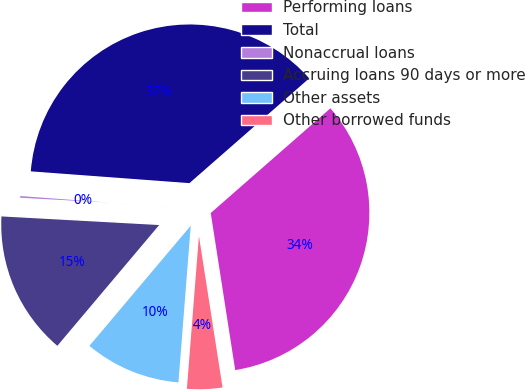<chart> <loc_0><loc_0><loc_500><loc_500><pie_chart><fcel>Performing loans<fcel>Total<fcel>Nonaccrual loans<fcel>Accruing loans 90 days or more<fcel>Other assets<fcel>Other borrowed funds<nl><fcel>33.98%<fcel>37.38%<fcel>0.31%<fcel>14.72%<fcel>9.9%<fcel>3.71%<nl></chart> 